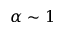Convert formula to latex. <formula><loc_0><loc_0><loc_500><loc_500>\alpha \sim 1</formula> 